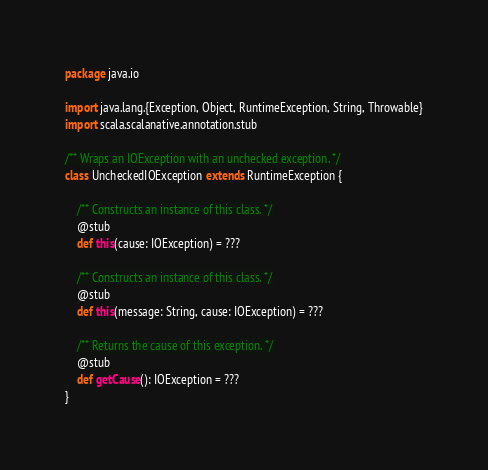Convert code to text. <code><loc_0><loc_0><loc_500><loc_500><_Scala_>package java.io

import java.lang.{Exception, Object, RuntimeException, String, Throwable}
import scala.scalanative.annotation.stub

/** Wraps an IOException with an unchecked exception. */
class UncheckedIOException extends RuntimeException {

    /** Constructs an instance of this class. */
    @stub
    def this(cause: IOException) = ???

    /** Constructs an instance of this class. */
    @stub
    def this(message: String, cause: IOException) = ???

    /** Returns the cause of this exception. */
    @stub
    def getCause(): IOException = ???
}
</code> 